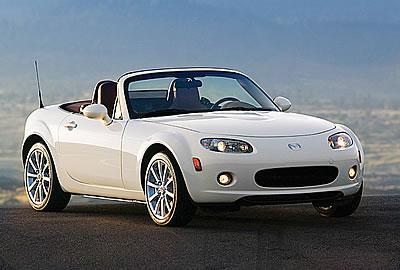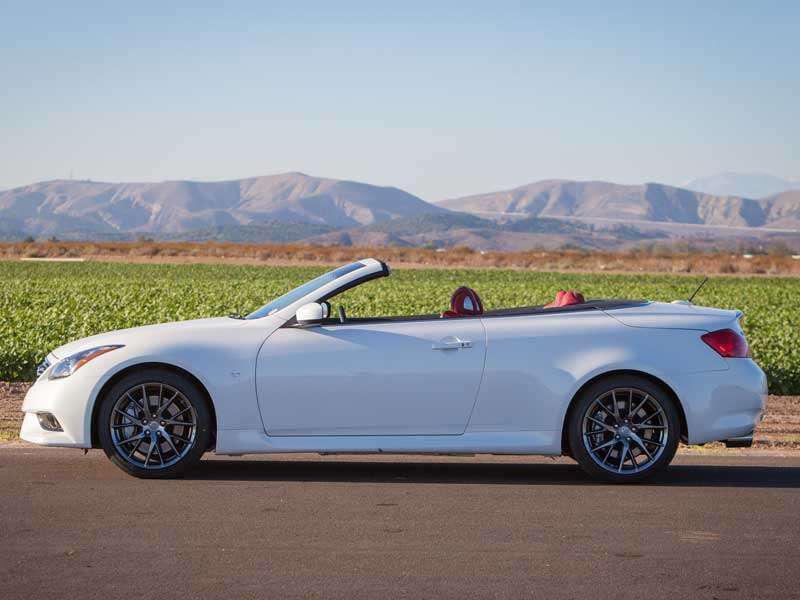The first image is the image on the left, the second image is the image on the right. Assess this claim about the two images: "The car in the image on the left is parked in front of a building.". Correct or not? Answer yes or no. No. The first image is the image on the left, the second image is the image on the right. Evaluate the accuracy of this statement regarding the images: "there is a parked convertible on the road in fron't of a mountain background". Is it true? Answer yes or no. Yes. 